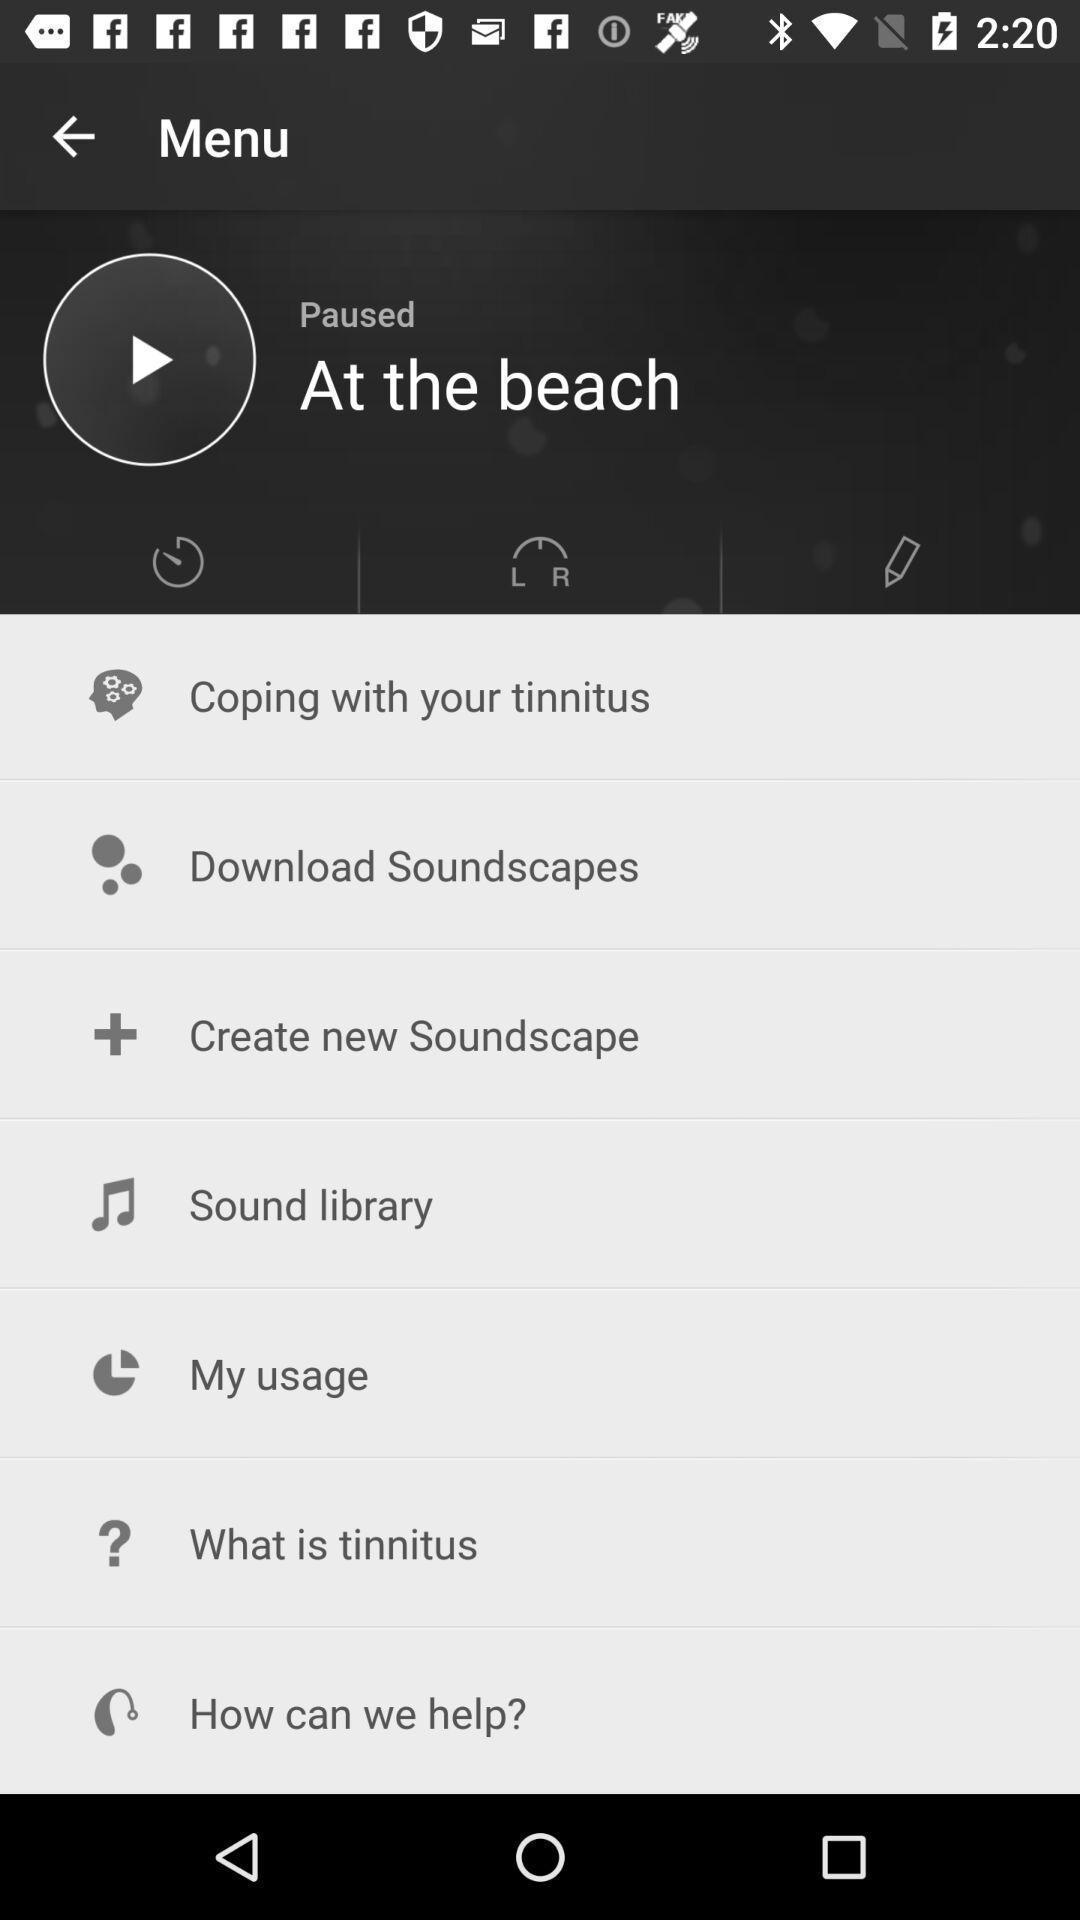Describe the key features of this screenshot. Page shows the menu list of music app. 